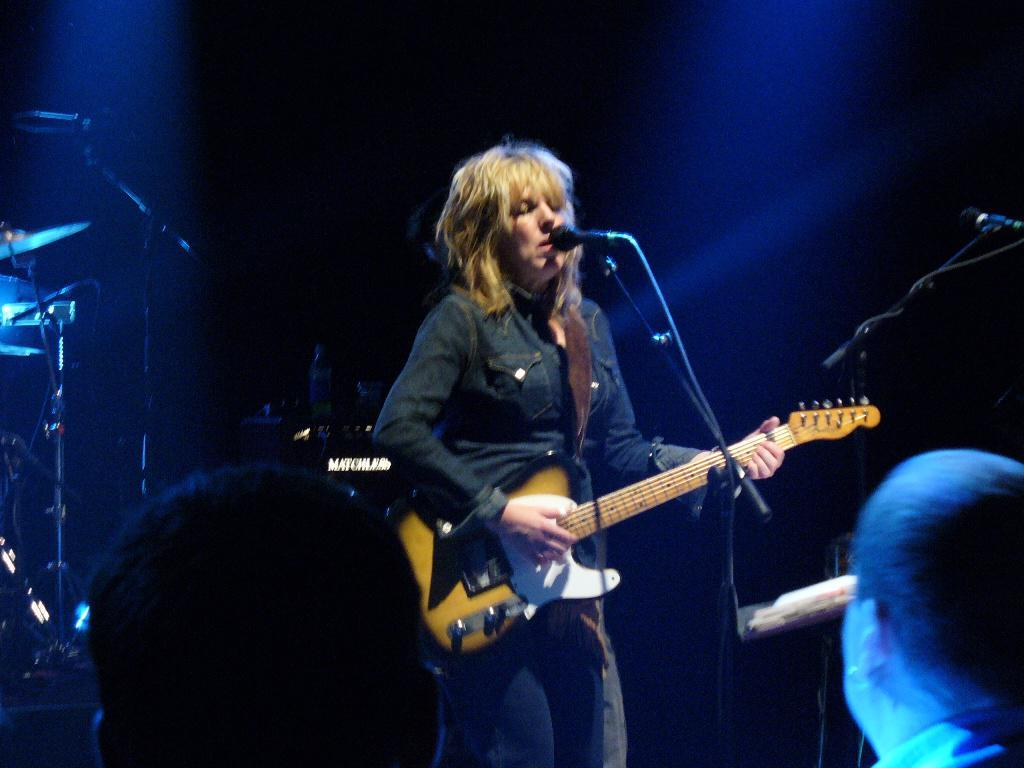How many people are in the image? There are three persons in the image. What is the woman holding in the image? The woman is holding a guitar. Where is the woman positioned in relation to the microphone? The woman is standing in front of a microphone. What can be seen in the background of the image? There is a musical instrument and light visible in the background. What type of powder is being used by the woman to play the guitar in the image? There is no powder visible in the image, and the woman is not using any powder to play the guitar. 